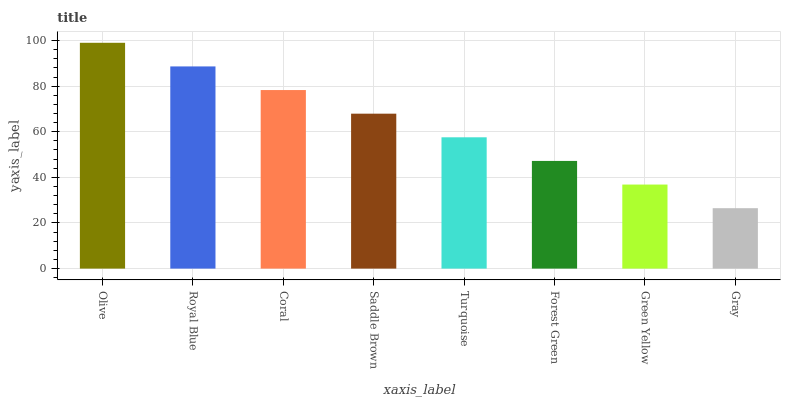Is Gray the minimum?
Answer yes or no. Yes. Is Olive the maximum?
Answer yes or no. Yes. Is Royal Blue the minimum?
Answer yes or no. No. Is Royal Blue the maximum?
Answer yes or no. No. Is Olive greater than Royal Blue?
Answer yes or no. Yes. Is Royal Blue less than Olive?
Answer yes or no. Yes. Is Royal Blue greater than Olive?
Answer yes or no. No. Is Olive less than Royal Blue?
Answer yes or no. No. Is Saddle Brown the high median?
Answer yes or no. Yes. Is Turquoise the low median?
Answer yes or no. Yes. Is Coral the high median?
Answer yes or no. No. Is Royal Blue the low median?
Answer yes or no. No. 